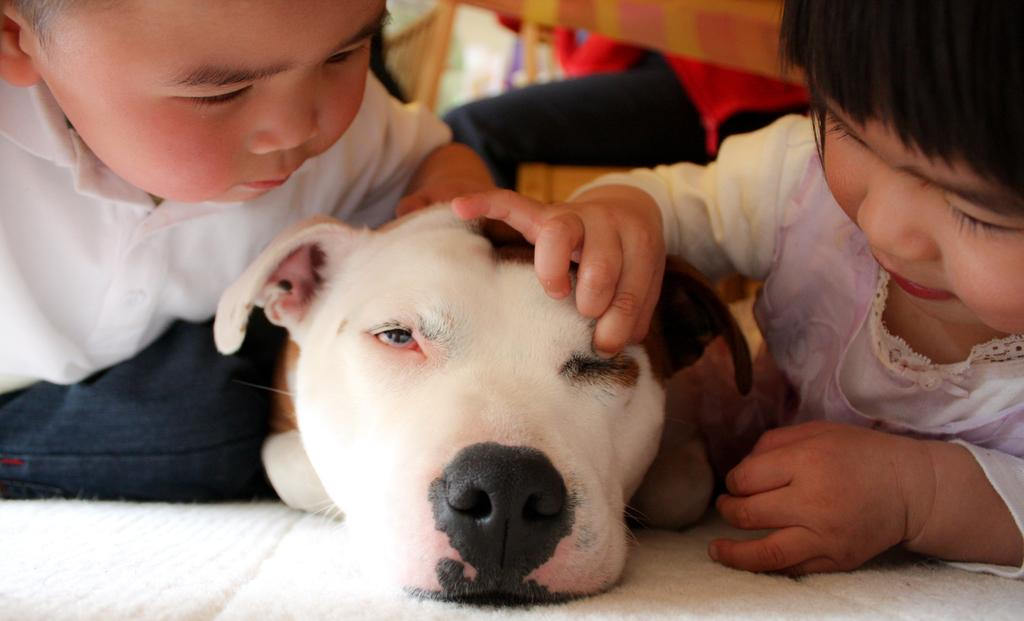What animal is at the center of the image? There is a dog in the image, and it is at the center. How many children are in the image? There are two children in the image. Where is each child located in relation to the dog? One child is on the right side of the image, and the other child is on the left side of the image. What are the children doing with the dog? The children are playing with the dog. What type of veil is being used by the dog in the image? There is no veil present in the image, and the dog is not using any type of veil. 